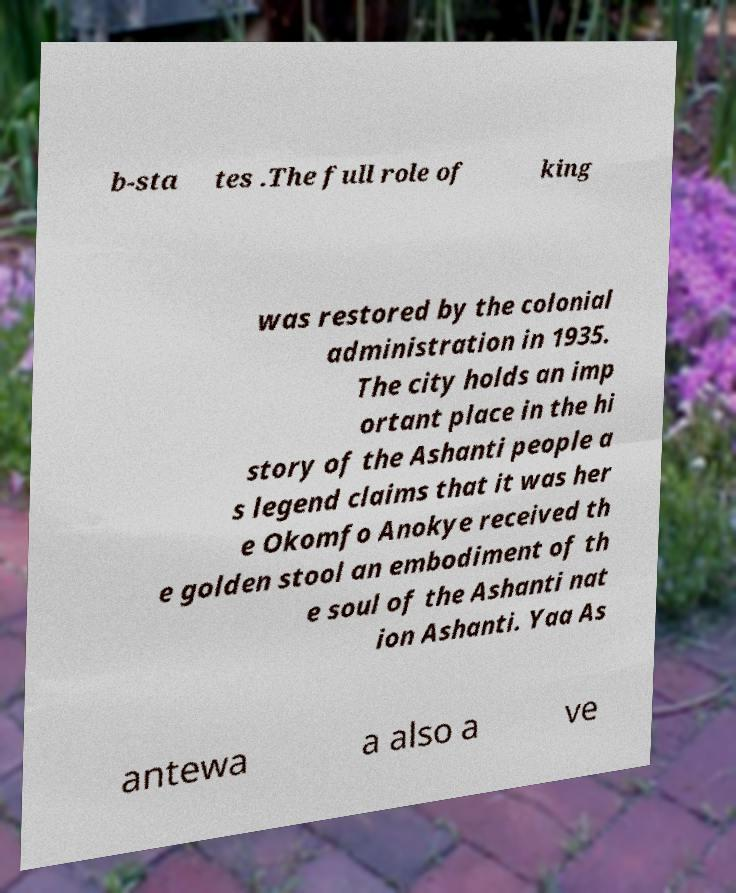Could you assist in decoding the text presented in this image and type it out clearly? b-sta tes .The full role of king was restored by the colonial administration in 1935. The city holds an imp ortant place in the hi story of the Ashanti people a s legend claims that it was her e Okomfo Anokye received th e golden stool an embodiment of th e soul of the Ashanti nat ion Ashanti. Yaa As antewa a also a ve 